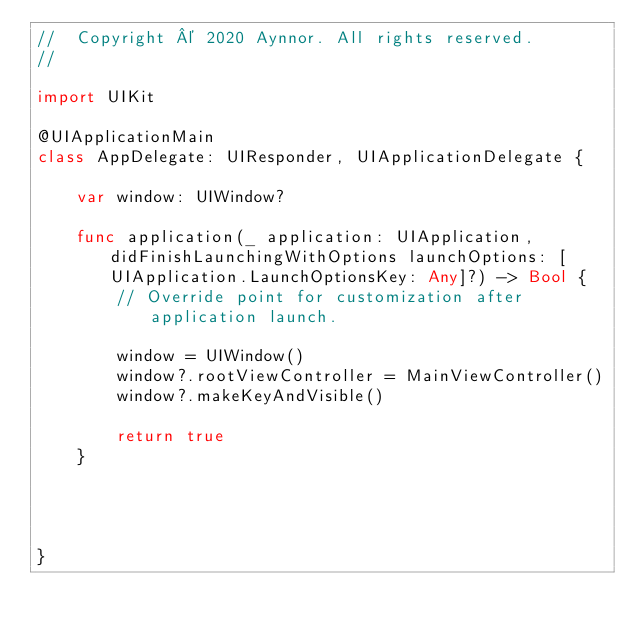<code> <loc_0><loc_0><loc_500><loc_500><_Swift_>//  Copyright © 2020 Aynnor. All rights reserved.
//

import UIKit

@UIApplicationMain
class AppDelegate: UIResponder, UIApplicationDelegate {

    var window: UIWindow?

    func application(_ application: UIApplication, didFinishLaunchingWithOptions launchOptions: [UIApplication.LaunchOptionsKey: Any]?) -> Bool {
        // Override point for customization after application launch.
        
        window = UIWindow()
        window?.rootViewController = MainViewController()
        window?.makeKeyAndVisible()
        
        return true
    }
    
    
    
    
}

</code> 